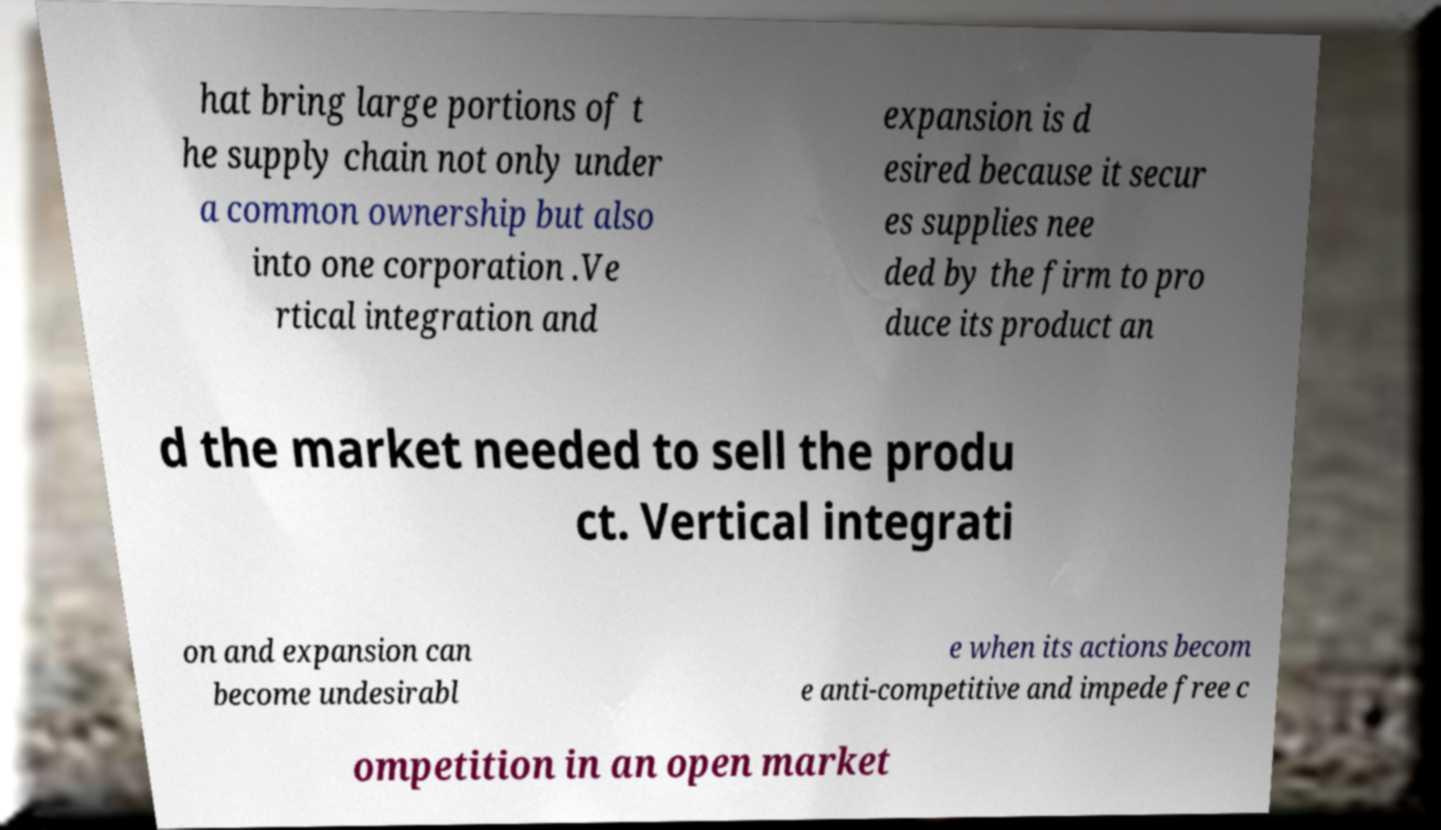There's text embedded in this image that I need extracted. Can you transcribe it verbatim? hat bring large portions of t he supply chain not only under a common ownership but also into one corporation .Ve rtical integration and expansion is d esired because it secur es supplies nee ded by the firm to pro duce its product an d the market needed to sell the produ ct. Vertical integrati on and expansion can become undesirabl e when its actions becom e anti-competitive and impede free c ompetition in an open market 